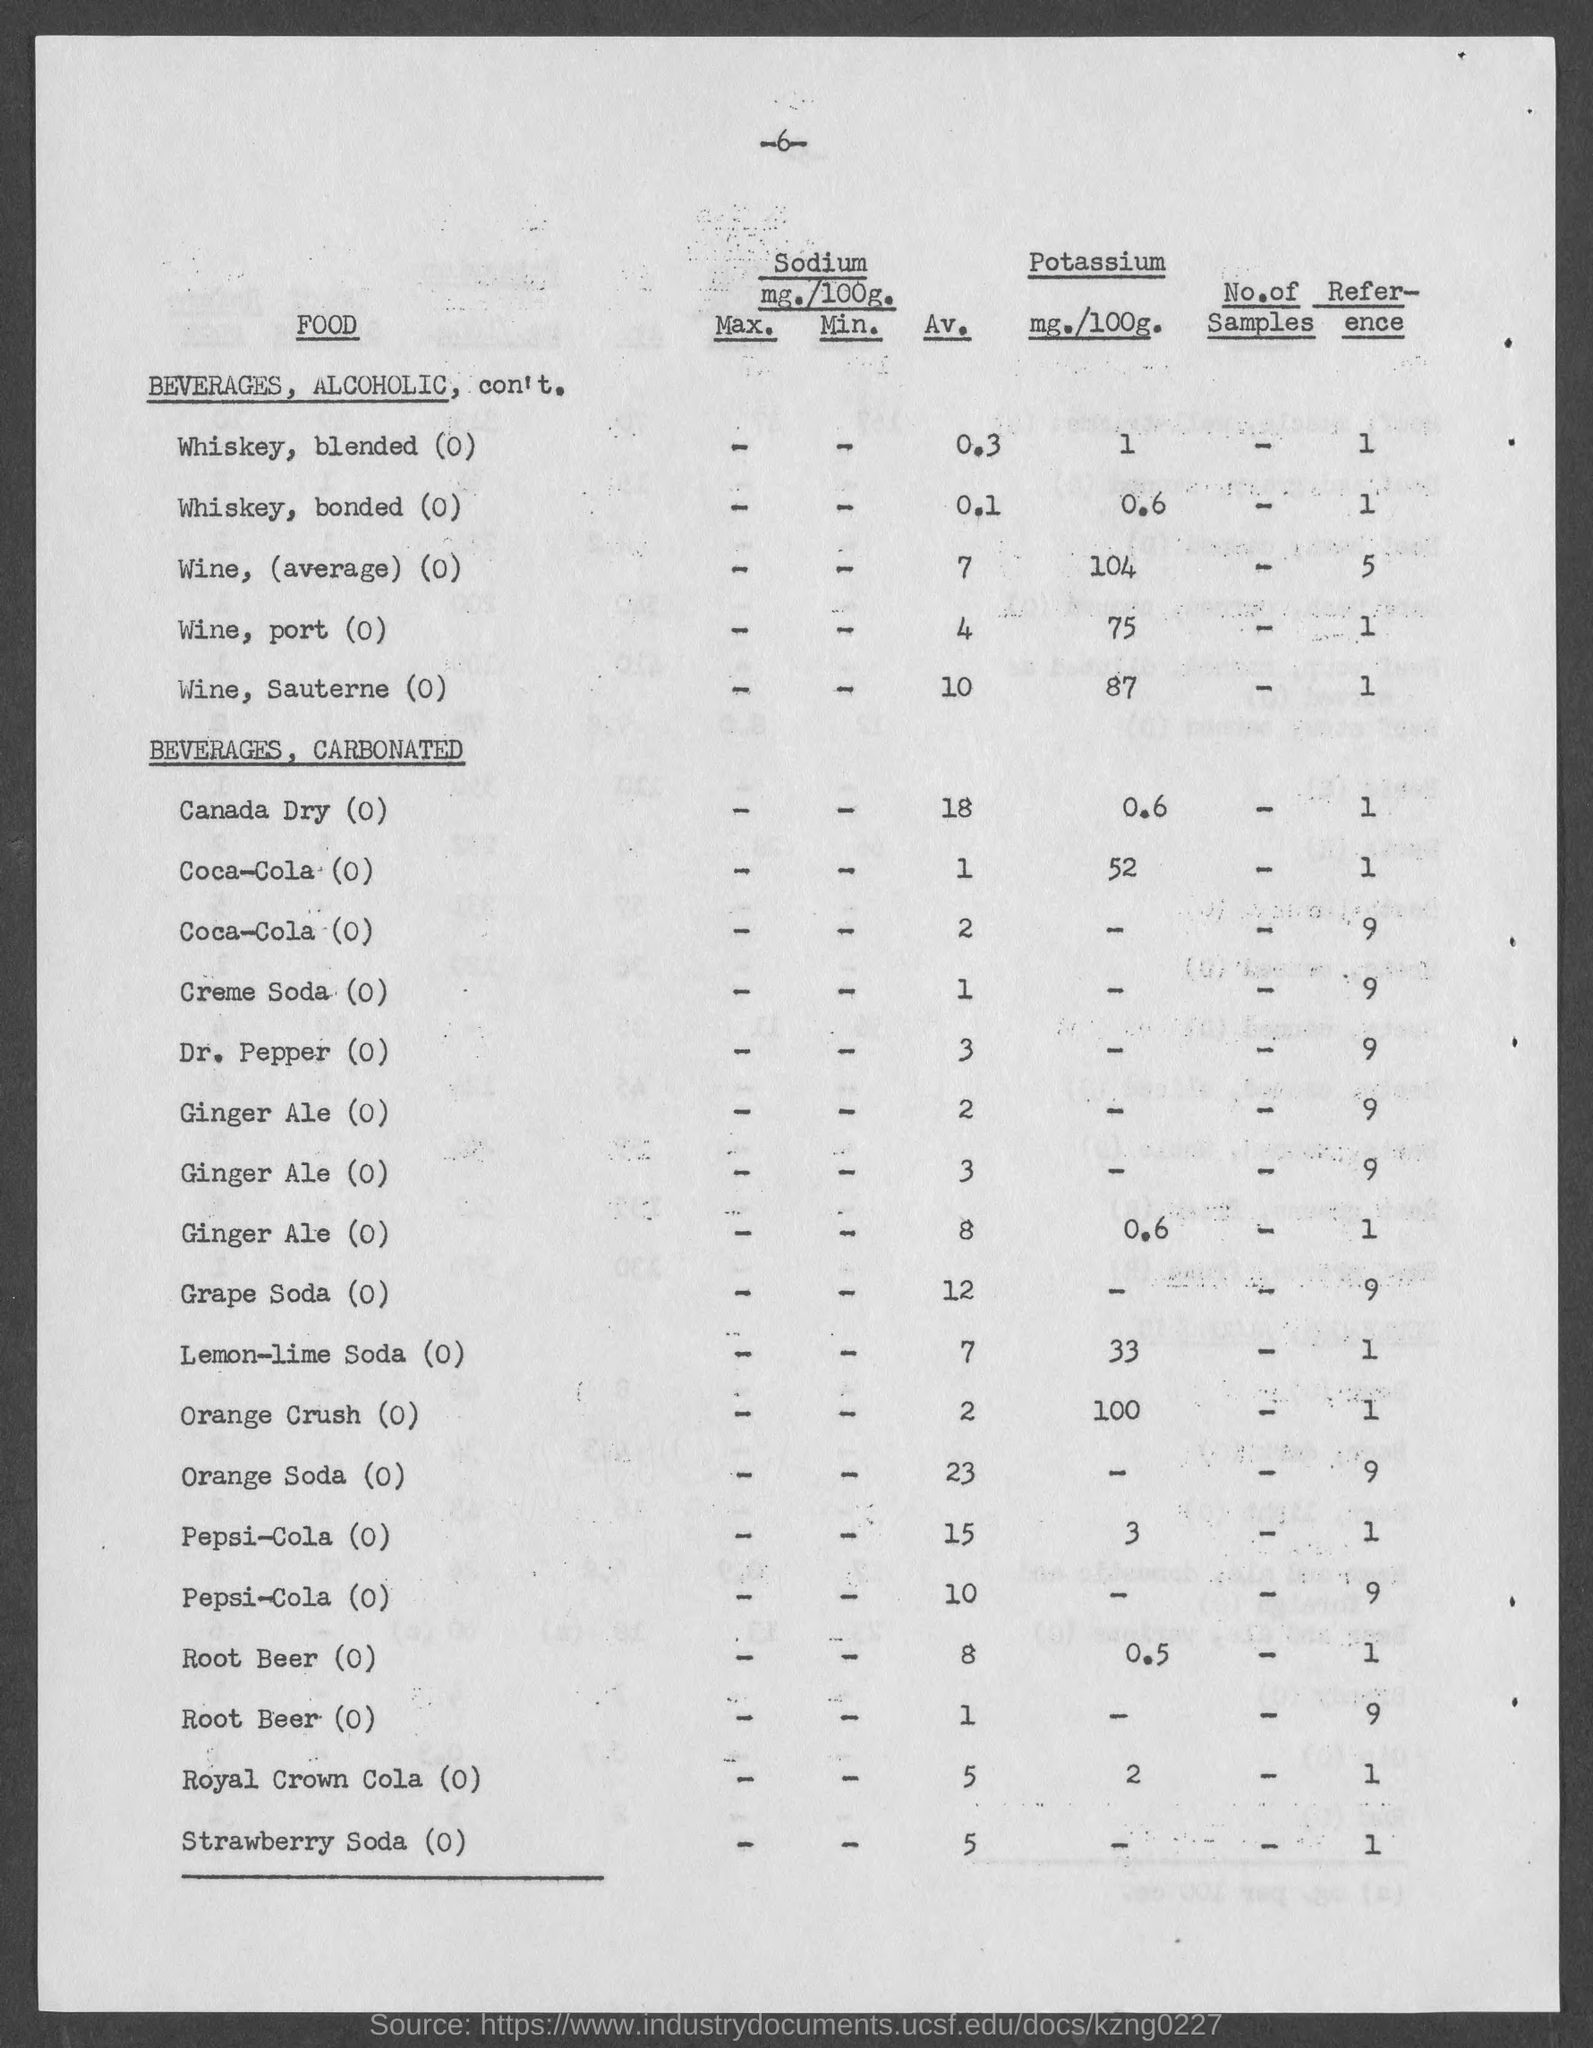What is the sodium mg./100g. for Whiskey, blended(0)?
Your answer should be compact. 0.3. 